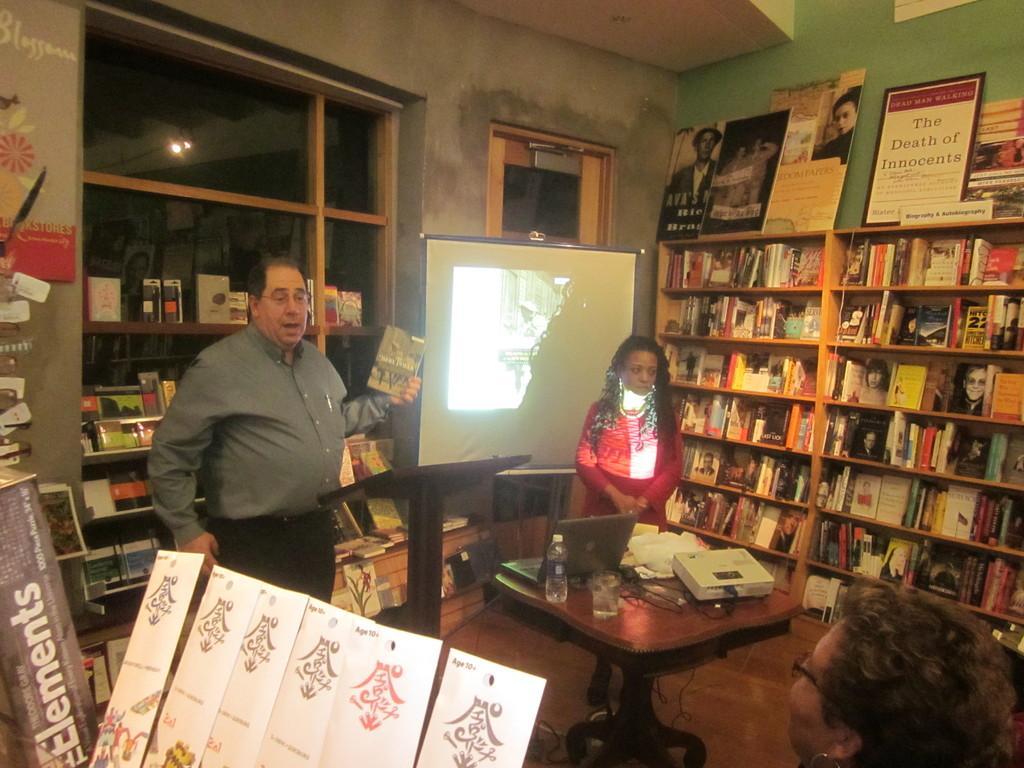Can you describe this image briefly? This is the picture of a room where we have two shelves in the right side in which some books are placed end to the other side there is another shelf on which books are placed and there are three people in the room among them one is sitting and the other two are standing in front of the screen and table on which some things are placed on it. 